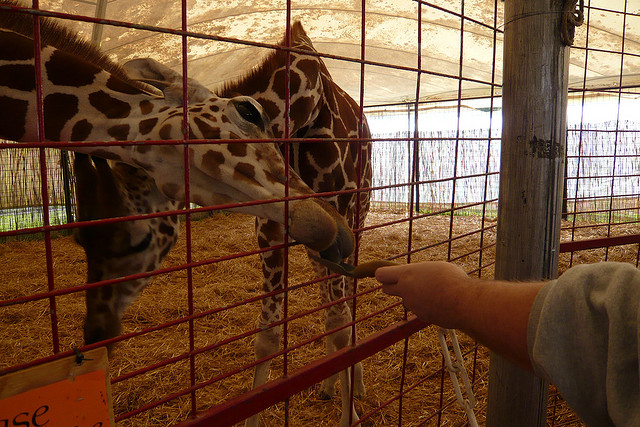Read and extract the text from this image. se 